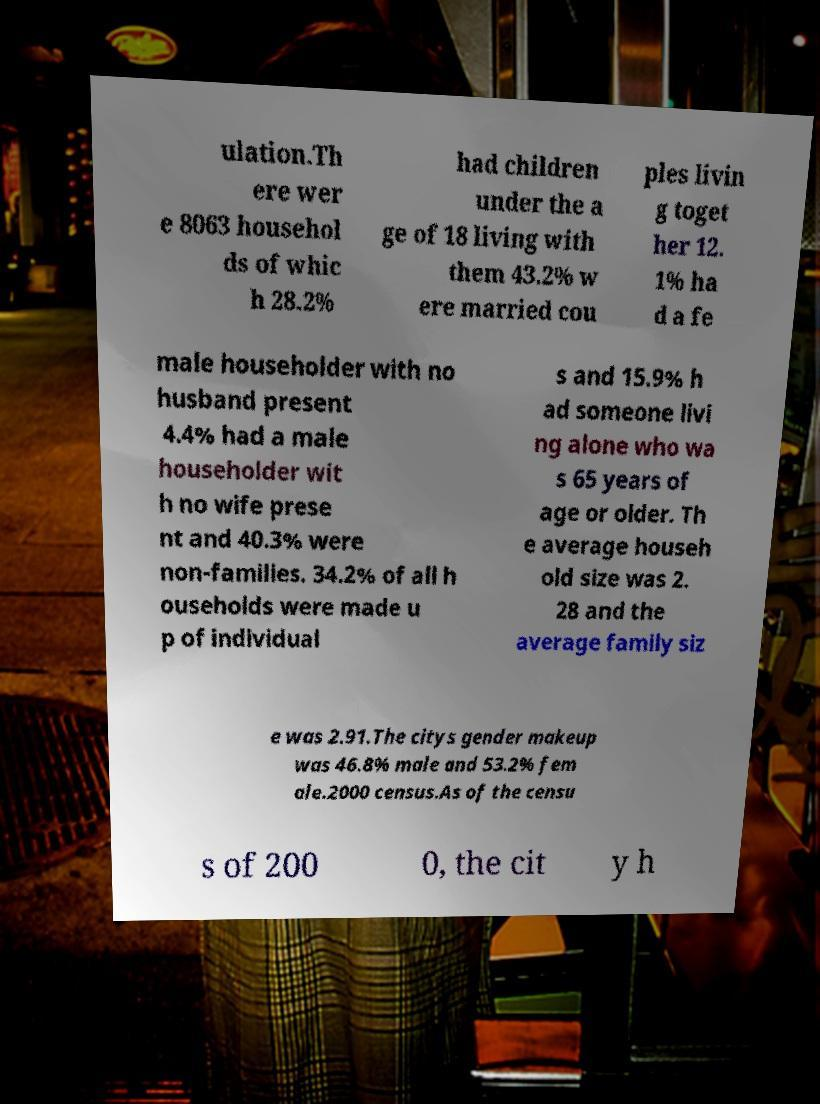For documentation purposes, I need the text within this image transcribed. Could you provide that? ulation.Th ere wer e 8063 househol ds of whic h 28.2% had children under the a ge of 18 living with them 43.2% w ere married cou ples livin g toget her 12. 1% ha d a fe male householder with no husband present 4.4% had a male householder wit h no wife prese nt and 40.3% were non-families. 34.2% of all h ouseholds were made u p of individual s and 15.9% h ad someone livi ng alone who wa s 65 years of age or older. Th e average househ old size was 2. 28 and the average family siz e was 2.91.The citys gender makeup was 46.8% male and 53.2% fem ale.2000 census.As of the censu s of 200 0, the cit y h 